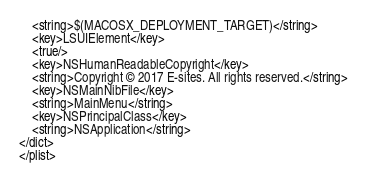<code> <loc_0><loc_0><loc_500><loc_500><_XML_>	<string>$(MACOSX_DEPLOYMENT_TARGET)</string>
	<key>LSUIElement</key>
	<true/>
	<key>NSHumanReadableCopyright</key>
	<string>Copyright © 2017 E-sites. All rights reserved.</string>
	<key>NSMainNibFile</key>
	<string>MainMenu</string>
	<key>NSPrincipalClass</key>
	<string>NSApplication</string>
</dict>
</plist>
</code> 